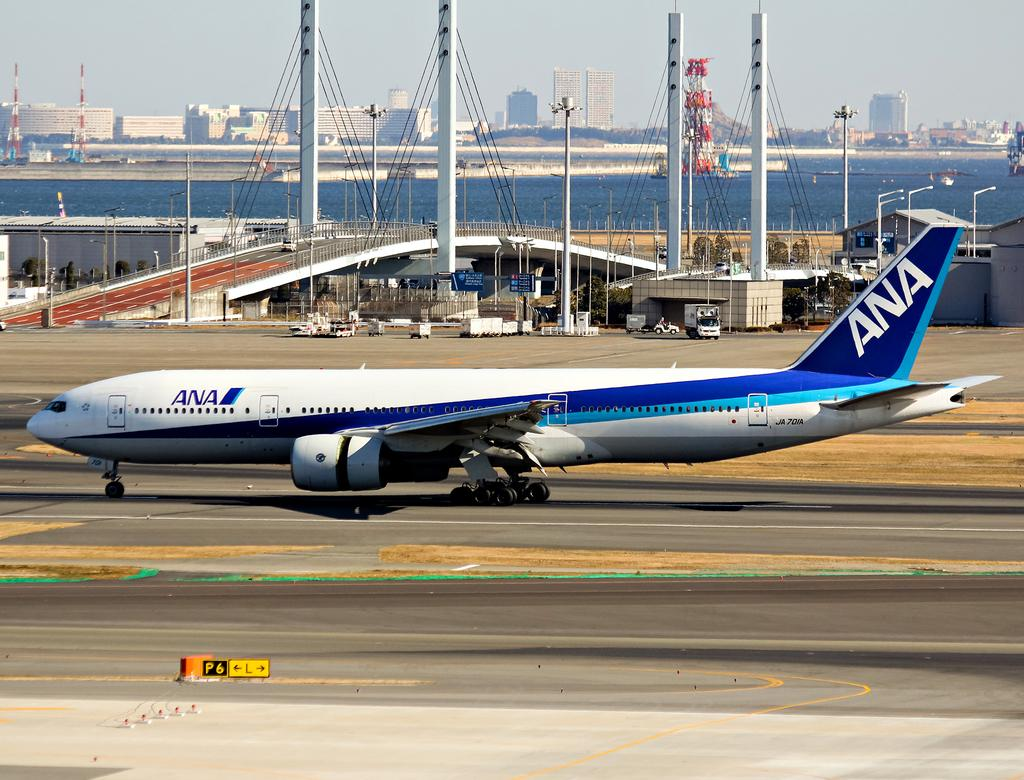<image>
Create a compact narrative representing the image presented. a plane on the runway with ANA written on the tail 